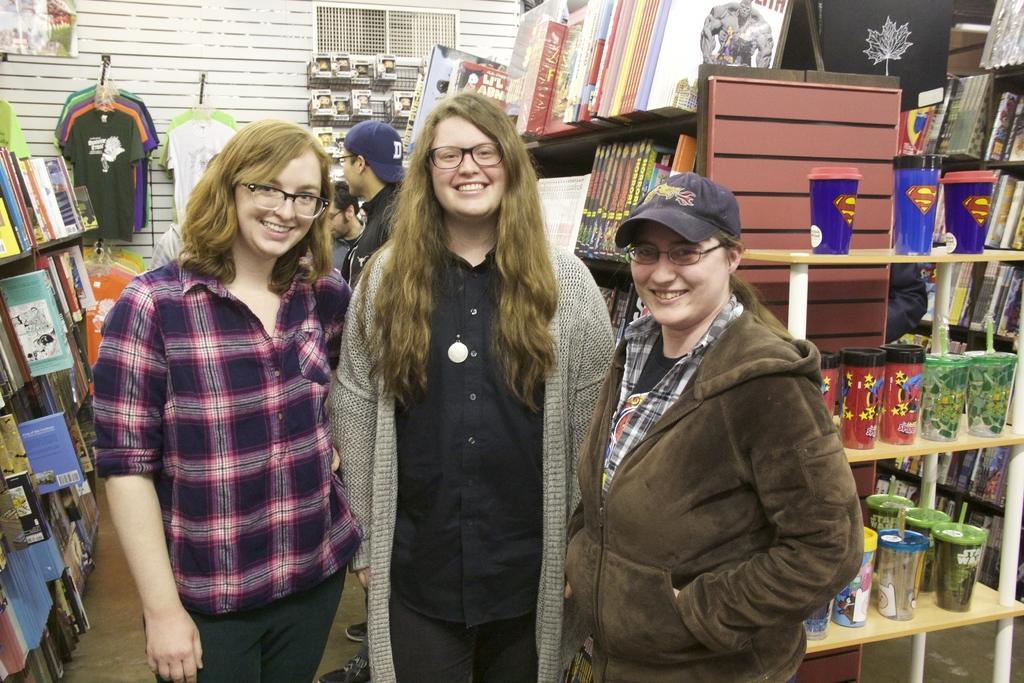Could you give a brief overview of what you see in this image? In the center of the image we can see three persons are standing and they are smiling and they are in different costumes. In the background there is a wall, shelves, books, clothes, plastic glasses, few people and a few other objects. 